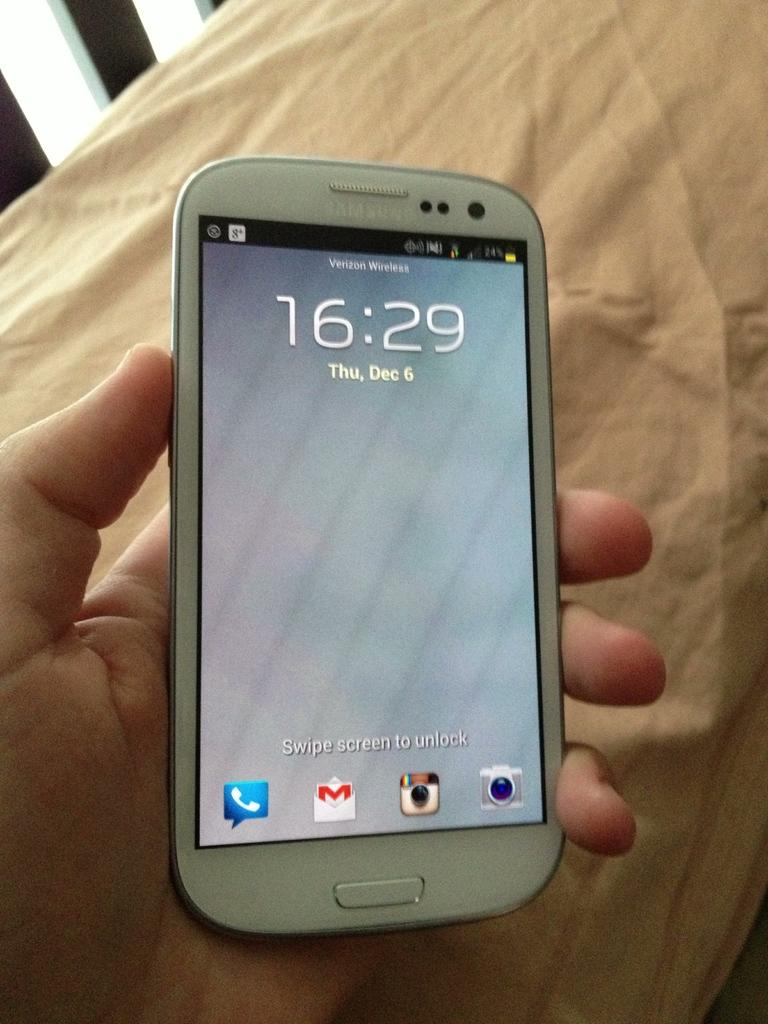<image>
Write a terse but informative summary of the picture. A white Samsung phone with Verizon Wireless as the carrier and the time showing as 16:29. 